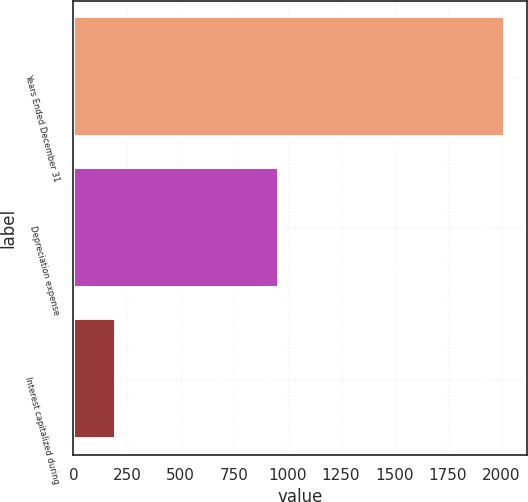<chart> <loc_0><loc_0><loc_500><loc_500><bar_chart><fcel>Years Ended December 31<fcel>Depreciation expense<fcel>Interest capitalized during<nl><fcel>2018<fcel>960<fcel>199<nl></chart> 